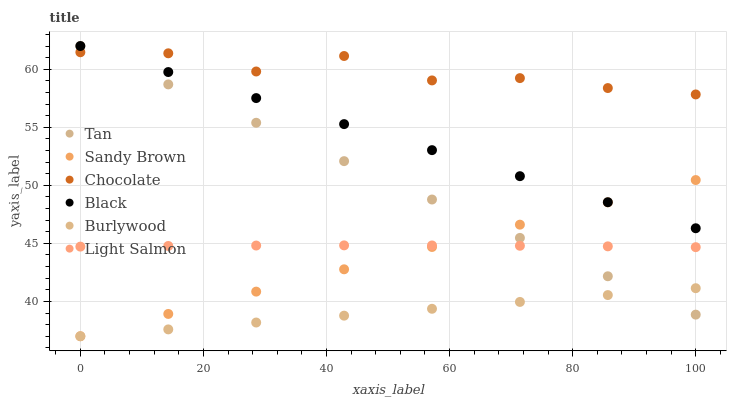Does Burlywood have the minimum area under the curve?
Answer yes or no. Yes. Does Chocolate have the maximum area under the curve?
Answer yes or no. Yes. Does Chocolate have the minimum area under the curve?
Answer yes or no. No. Does Burlywood have the maximum area under the curve?
Answer yes or no. No. Is Tan the smoothest?
Answer yes or no. Yes. Is Chocolate the roughest?
Answer yes or no. Yes. Is Burlywood the smoothest?
Answer yes or no. No. Is Burlywood the roughest?
Answer yes or no. No. Does Burlywood have the lowest value?
Answer yes or no. Yes. Does Chocolate have the lowest value?
Answer yes or no. No. Does Tan have the highest value?
Answer yes or no. Yes. Does Chocolate have the highest value?
Answer yes or no. No. Is Sandy Brown less than Chocolate?
Answer yes or no. Yes. Is Light Salmon greater than Burlywood?
Answer yes or no. Yes. Does Sandy Brown intersect Burlywood?
Answer yes or no. Yes. Is Sandy Brown less than Burlywood?
Answer yes or no. No. Is Sandy Brown greater than Burlywood?
Answer yes or no. No. Does Sandy Brown intersect Chocolate?
Answer yes or no. No. 